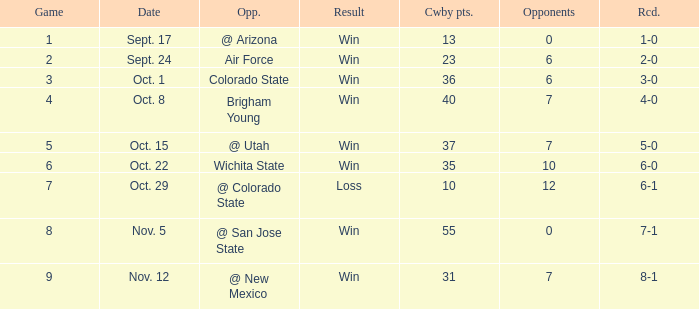When did the Cowboys score 13 points in 1966? Sept. 17. Give me the full table as a dictionary. {'header': ['Game', 'Date', 'Opp.', 'Result', 'Cwby pts.', 'Opponents', 'Rcd.'], 'rows': [['1', 'Sept. 17', '@ Arizona', 'Win', '13', '0', '1-0'], ['2', 'Sept. 24', 'Air Force', 'Win', '23', '6', '2-0'], ['3', 'Oct. 1', 'Colorado State', 'Win', '36', '6', '3-0'], ['4', 'Oct. 8', 'Brigham Young', 'Win', '40', '7', '4-0'], ['5', 'Oct. 15', '@ Utah', 'Win', '37', '7', '5-0'], ['6', 'Oct. 22', 'Wichita State', 'Win', '35', '10', '6-0'], ['7', 'Oct. 29', '@ Colorado State', 'Loss', '10', '12', '6-1'], ['8', 'Nov. 5', '@ San Jose State', 'Win', '55', '0', '7-1'], ['9', 'Nov. 12', '@ New Mexico', 'Win', '31', '7', '8-1']]} 